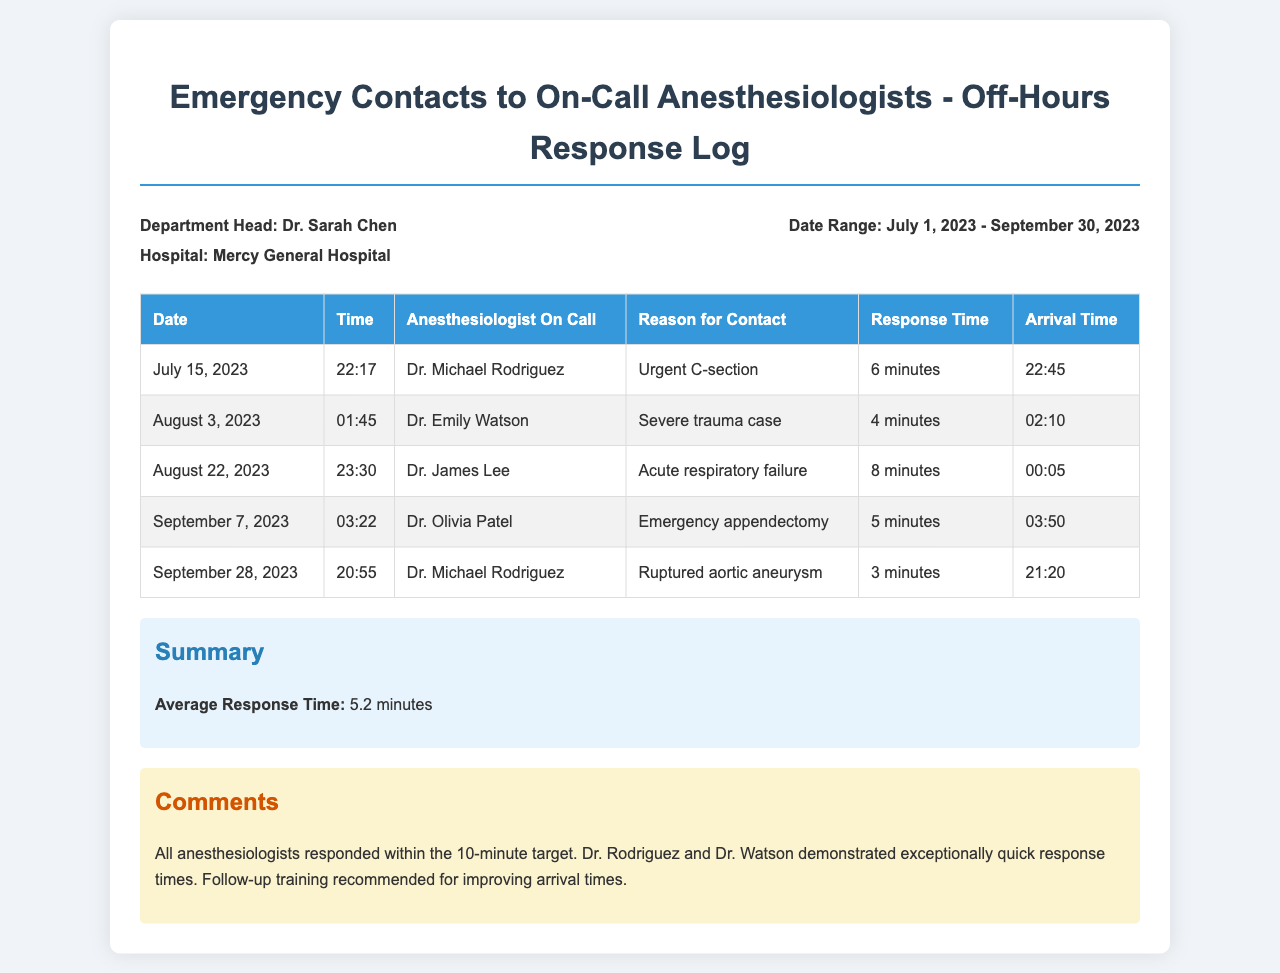what was the average response time for anesthesiologists? The average response time is calculated from all the recorded response times in the document.
Answer: 5.2 minutes who was the anesthesiologist on call for the emergency appendectomy? The document lists the anesthesiologists along with the procedures they were contacted for during off-hours.
Answer: Dr. Olivia Patel on what date did Dr. Michael Rodriguez respond to the ruptured aortic aneurysm case? The document provides a detailed log of contacts including dates and respective anesthesiologists for specific cases.
Answer: September 28, 2023 which reason for contact had the fastest response time? The response times for each contact are listed in the document, and the fastest can be identified by comparing them.
Answer: Ruptured aortic aneurysm how many emergency contacts were recorded in total? By counting the instances in the table, one can determine the total number of contacts made to anesthesiologists during the specified period.
Answer: 5 